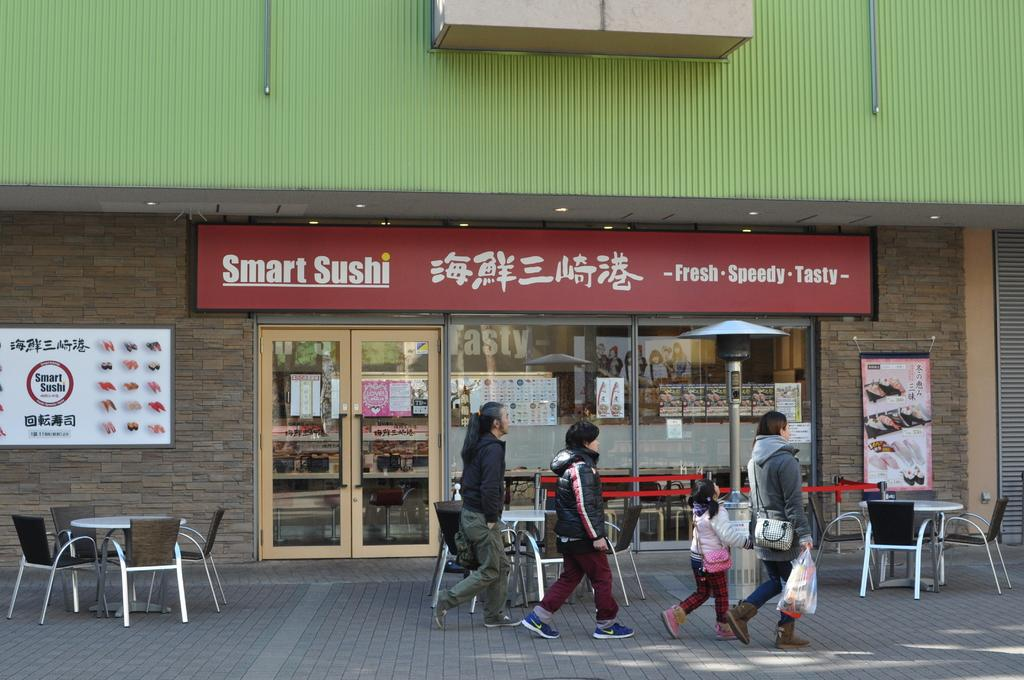How many people are in the image? There are three persons in the image. Can you describe the youngest person in the image? There is a child in the image. Where are the persons and child located? They are on a path in the image. What can be seen in the background of the image? There are tables and chairs, as well as a shop visible in the image. What is on the wall in the image? There are boards on a wall in the image. What type of string is being used to hold the family together in the image? There is no string or family present in the image; it features three persons and a child on a path. 